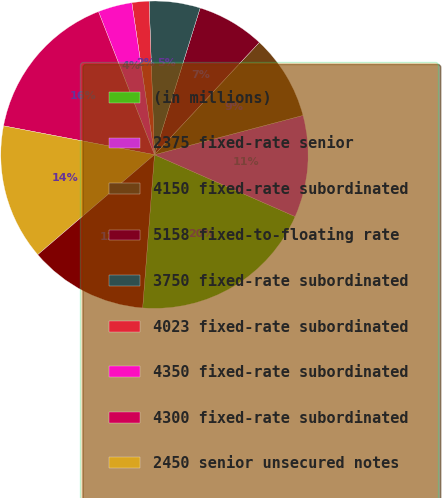<chart> <loc_0><loc_0><loc_500><loc_500><pie_chart><fcel>(in millions)<fcel>2375 fixed-rate senior<fcel>4150 fixed-rate subordinated<fcel>5158 fixed-to-floating rate<fcel>3750 fixed-rate subordinated<fcel>4023 fixed-rate subordinated<fcel>4350 fixed-rate subordinated<fcel>4300 fixed-rate subordinated<fcel>2450 senior unsecured notes<fcel>2500 senior unsecured notes<nl><fcel>19.63%<fcel>10.71%<fcel>8.93%<fcel>7.15%<fcel>5.36%<fcel>1.8%<fcel>3.58%<fcel>16.06%<fcel>14.28%<fcel>12.5%<nl></chart> 